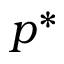Convert formula to latex. <formula><loc_0><loc_0><loc_500><loc_500>p ^ { * }</formula> 